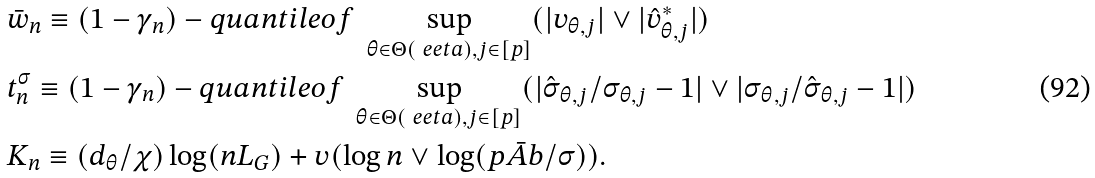<formula> <loc_0><loc_0><loc_500><loc_500>& \bar { w } _ { n } \equiv ( 1 - \gamma _ { n } ) - q u a n t i l e o f \ \sup _ { \theta \in \Theta ( \ e e t a ) , j \in [ p ] } ( | v _ { \theta , j } | \vee | \hat { v } _ { \theta , j } ^ { * } | ) \\ & t _ { n } ^ { \sigma } \equiv ( 1 - \gamma _ { n } ) - q u a n t i l e o f \ \sup _ { \theta \in \Theta ( \ e e t a ) , j \in [ p ] } ( | \hat { \sigma } _ { \theta , j } / \sigma _ { \theta , j } - 1 | \vee | \sigma _ { \theta , j } / \hat { \sigma } _ { \theta , j } - 1 | ) \\ & K _ { n } \equiv ( d _ { \theta } / \chi ) \log ( n L _ { G } ) + v ( \log n \vee \log ( p \bar { A } b / \sigma ) ) .</formula> 